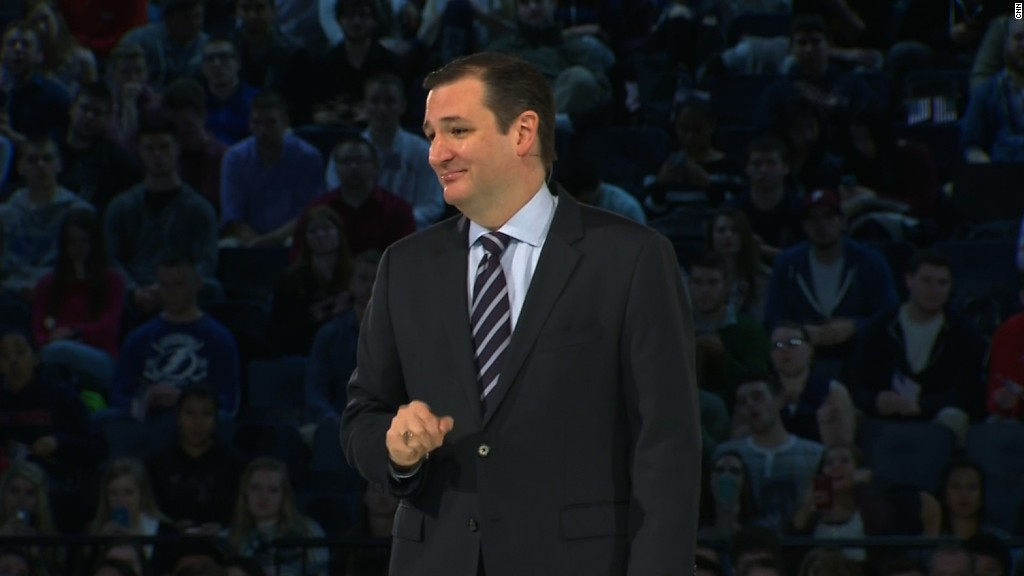If the speaker were an AI-hologram giving a speech about the future of education, what might be the key focus points of the presentation? If the speaker were an AI-hologram giving a speech on the future of education, key focus points might include:
1. Personalized Learning: AI could tailor educational experiences to individual learning styles and paces.
2. Gamification: Leveraging game-based learning environments to increase student engagement.
3. Virtual Reality and Augmented Reality: Introducing immersive environments to simulate real-world experiences.
4. Lifelong Learning: Emphasizing the importance of continuous education in a rapidly changing job market.
5. Global Classroom: Breaking down geographical barriers by connecting classrooms worldwide through digital platforms.
6. Skill-based Education: Focusing more on practical skills and less on rote memorization.
7. AI Tutors: Using intelligent virtual assistants to provide 24/7 academic support to students. In the context of this futuristic scenario, how might students interact with each other and the AI-hologram? Students in this futuristic scenario might use various advanced communication tools to interact with each other and the AI-hologram. These interactions could include:
1. Real-time Polling and Q&A: Students could use their devices to ask questions and participate in polls, with the AI-hologram responding instantly.
2. Group Collaborations: Virtual rooms and holographic displays enable students to collaborate on projects in real-time, regardless of their physical location.
3. Personal AI Assistants: Each student might have an AI assistant to help them process the information presented, take notes, and suggest further reading.
4. Holographic Chats: Instead of traditional text-based messages, students could engage in holographic chats, making discussions feel more personal and interactive.
5. Immersive Workshops: Virtual reality could allow students to participate in hands-on workshops, carrying out experiments or simulations guided by the AI-hologram. 